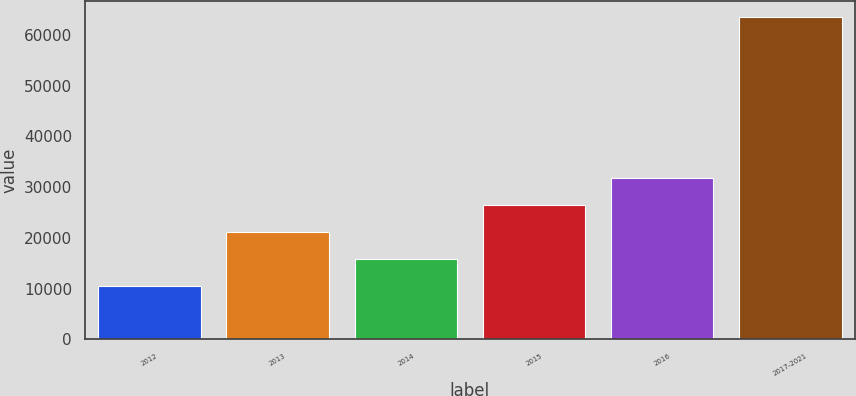Convert chart to OTSL. <chart><loc_0><loc_0><loc_500><loc_500><bar_chart><fcel>2012<fcel>2013<fcel>2014<fcel>2015<fcel>2016<fcel>2017-2021<nl><fcel>10521<fcel>21111.6<fcel>15816.3<fcel>26406.9<fcel>31702.2<fcel>63474<nl></chart> 